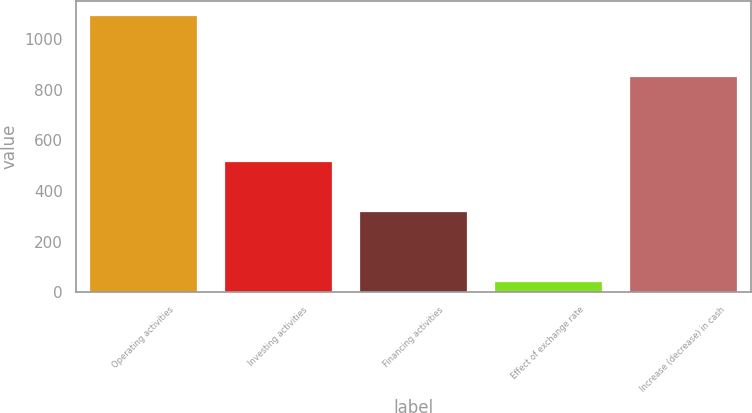Convert chart to OTSL. <chart><loc_0><loc_0><loc_500><loc_500><bar_chart><fcel>Operating activities<fcel>Investing activities<fcel>Financing activities<fcel>Effect of exchange rate<fcel>Increase (decrease) in cash<nl><fcel>1094<fcel>517<fcel>319<fcel>44<fcel>852<nl></chart> 